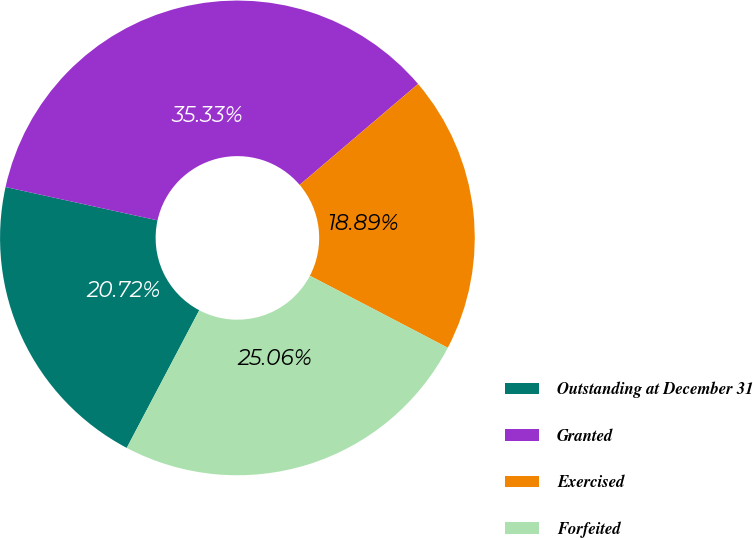Convert chart to OTSL. <chart><loc_0><loc_0><loc_500><loc_500><pie_chart><fcel>Outstanding at December 31<fcel>Granted<fcel>Exercised<fcel>Forfeited<nl><fcel>20.72%<fcel>35.33%<fcel>18.89%<fcel>25.06%<nl></chart> 